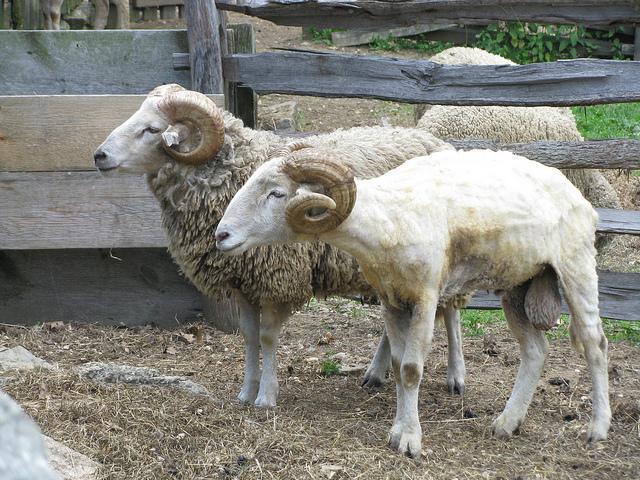How many sheep are there?
Give a very brief answer. 3. How many people are wearing orange shirts in the picture?
Give a very brief answer. 0. 